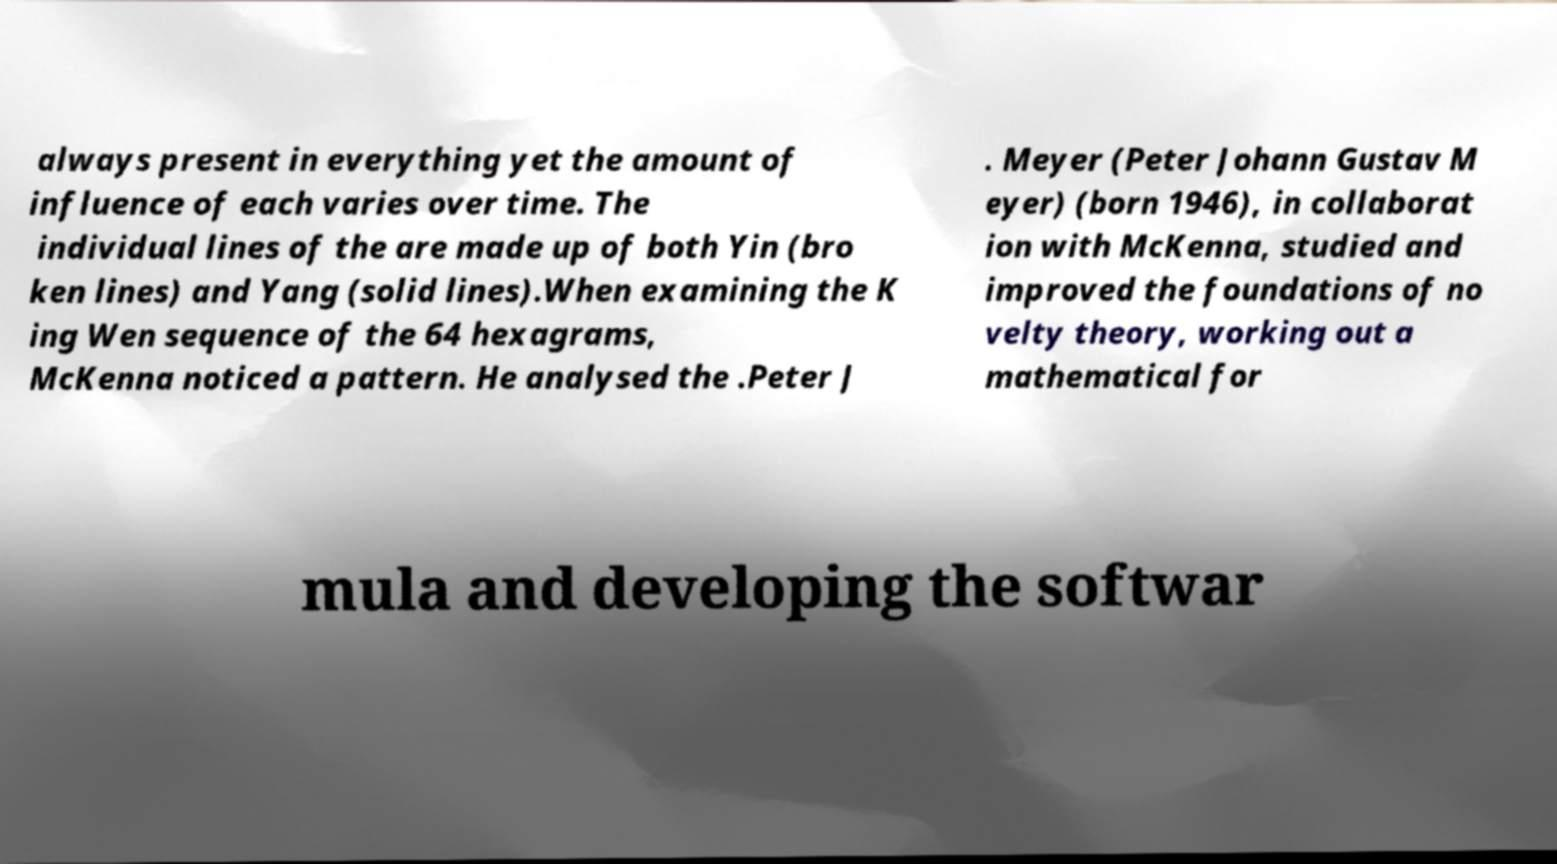There's text embedded in this image that I need extracted. Can you transcribe it verbatim? always present in everything yet the amount of influence of each varies over time. The individual lines of the are made up of both Yin (bro ken lines) and Yang (solid lines).When examining the K ing Wen sequence of the 64 hexagrams, McKenna noticed a pattern. He analysed the .Peter J . Meyer (Peter Johann Gustav M eyer) (born 1946), in collaborat ion with McKenna, studied and improved the foundations of no velty theory, working out a mathematical for mula and developing the softwar 